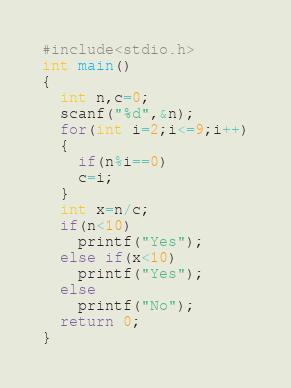Convert code to text. <code><loc_0><loc_0><loc_500><loc_500><_C_>#include<stdio.h>
int main()
{
  int n,c=0;
  scanf("%d",&n);
  for(int i=2;i<=9;i++)
  {
    if(n%i==0)
    c=i;
  }
  int x=n/c;
  if(n<10)
    printf("Yes");
  else if(x<10)
    printf("Yes");
  else
    printf("No");
  return 0;
}
</code> 